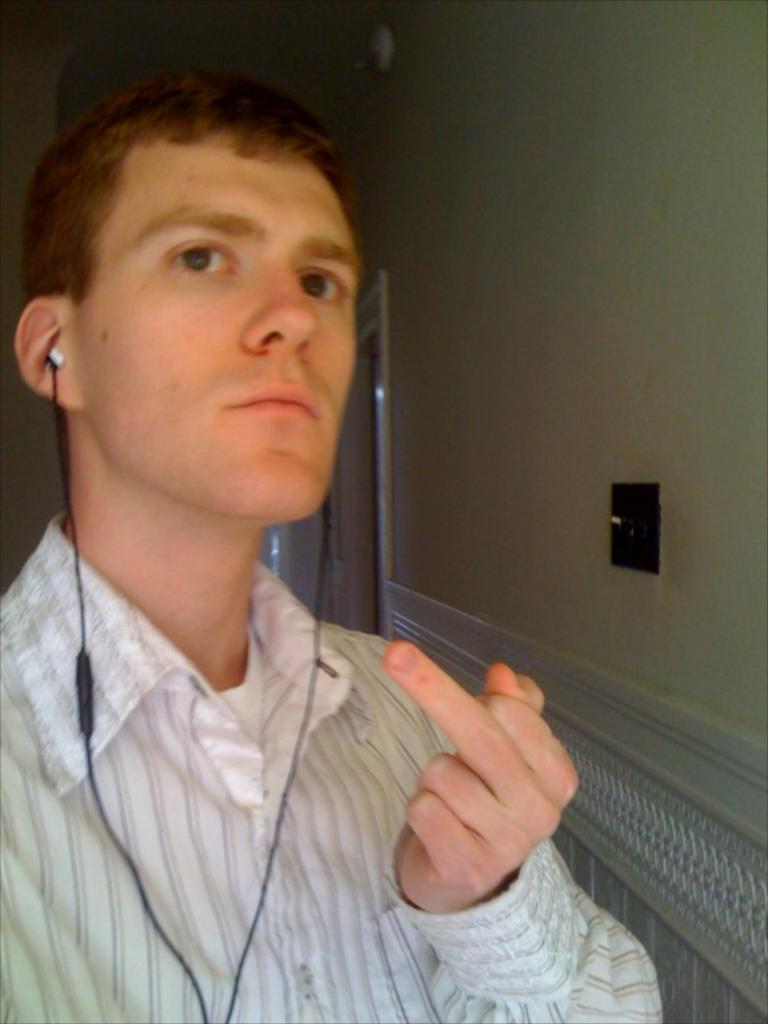Who is the main subject in the foreground of the image? There is a man in the foreground of the image. What is the man wearing in the image? The man is wearing earphones. What can be seen behind the man in the image? There is a wall visible behind the man. How many passengers are on the flight in the image? There is no flight or passengers present in the image; it features a man wearing earphones in the foreground and a wall in the background. 